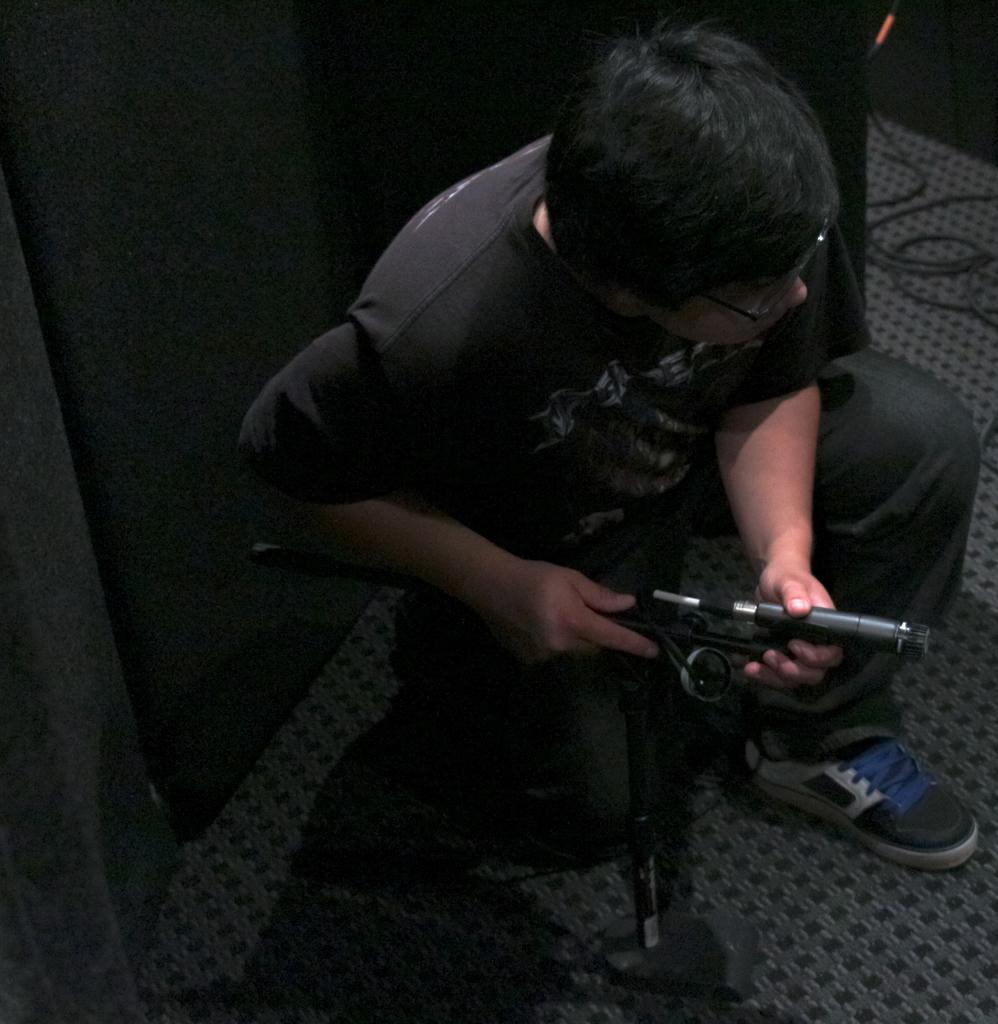What is the main subject of the picture? The main subject of the picture is a kid. What is the kid wearing in the image? The kid is wearing a black dress. What is the kid doing in the image? The kid is crouching down. What is the kid holding in the image? The kid is holding an object on the floor. What news story is the kid reporting on in the image? There is no news story or reporting activity depicted in the image. 